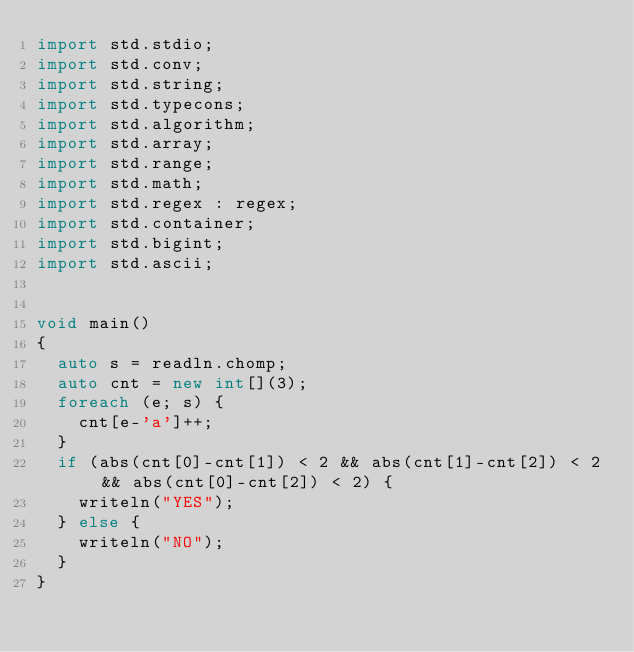<code> <loc_0><loc_0><loc_500><loc_500><_D_>import std.stdio;
import std.conv;
import std.string;
import std.typecons;
import std.algorithm;
import std.array;
import std.range;
import std.math;
import std.regex : regex;
import std.container;
import std.bigint;
import std.ascii;


void main()
{
  auto s = readln.chomp;
  auto cnt = new int[](3);
  foreach (e; s) {
    cnt[e-'a']++;
  }
  if (abs(cnt[0]-cnt[1]) < 2 && abs(cnt[1]-cnt[2]) < 2 && abs(cnt[0]-cnt[2]) < 2) {
    writeln("YES");
  } else {
    writeln("NO");
  }
}
</code> 